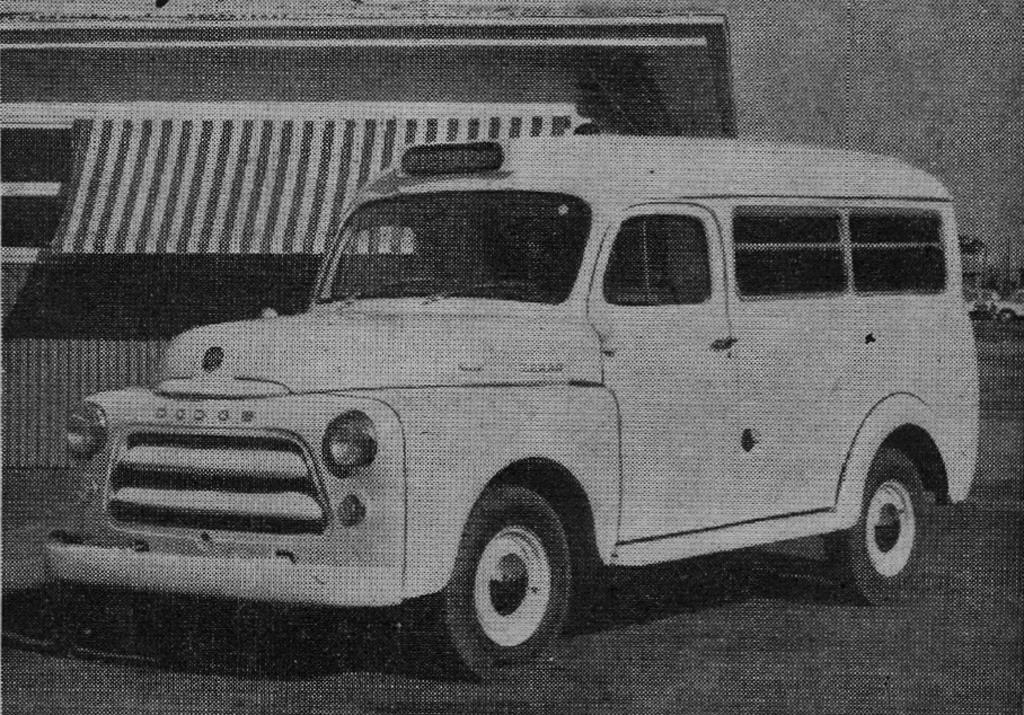What is the color scheme of the image? The image is black and white. What can be seen on the road in the image? There is a car on the road in the image. What structure is located on the left side of the image? There appears to be a building on the left side of the image. What else can be seen on the road in the image? There are other cars on the right side of the image. What type of recess can be seen in the image? There is no recess present in the image; it features a car on the road and a building on the left side. What color is the sock on the car in the image? There is no sock present on the car in the image. 